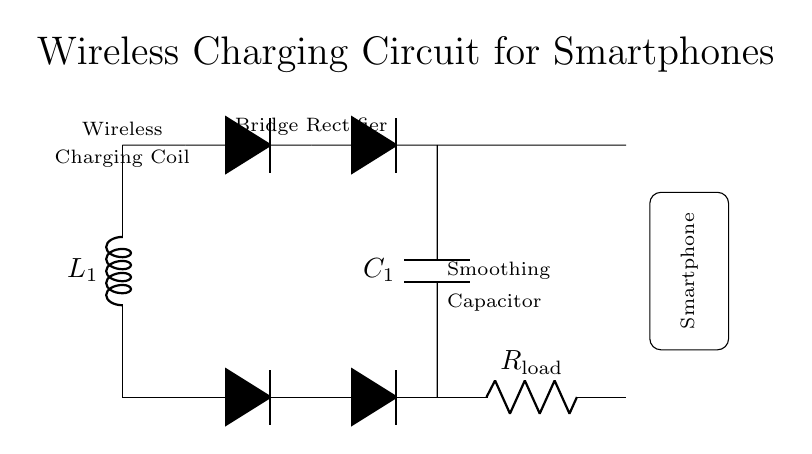What does L1 represent in the circuit? L1 represents the wireless charging coil, which is an inductor used to create a magnetic field for wireless energy transfer.
Answer: wireless charging coil What type of rectifier is used in this circuit? The circuit uses a bridge rectifier, which consists of four diodes arranged to convert alternating current from the charging coil into direct current for the load.
Answer: bridge rectifier How many diodes are present in the rectifier section? There are four diodes in the rectifier section, needed to form the bridge configuration for effective AC to DC conversion.
Answer: four What purpose does C1 serve in this circuit? C1 is a smoothing capacitor that stabilizes the output voltage by reducing ripple, allowing for a more consistent DC output to the load.
Answer: smoothing What does R load represent in the circuit? R load represents the load resistor that simulates the load of a smartphone, determining how much current will flow through the circuit based on the voltage delivered.
Answer: smartphone load How does the wireless charging coil generate voltage? The wireless charging coil generates voltage through electromagnetic induction when it is placed in a variable magnetic field created by another coil in the charging station.
Answer: electromagnetic induction What is the type of current supplied to the smartphone? The smartphone receives direct current (DC) after the AC is converted by the bridge rectifier, suitable for charging the device.
Answer: direct current 